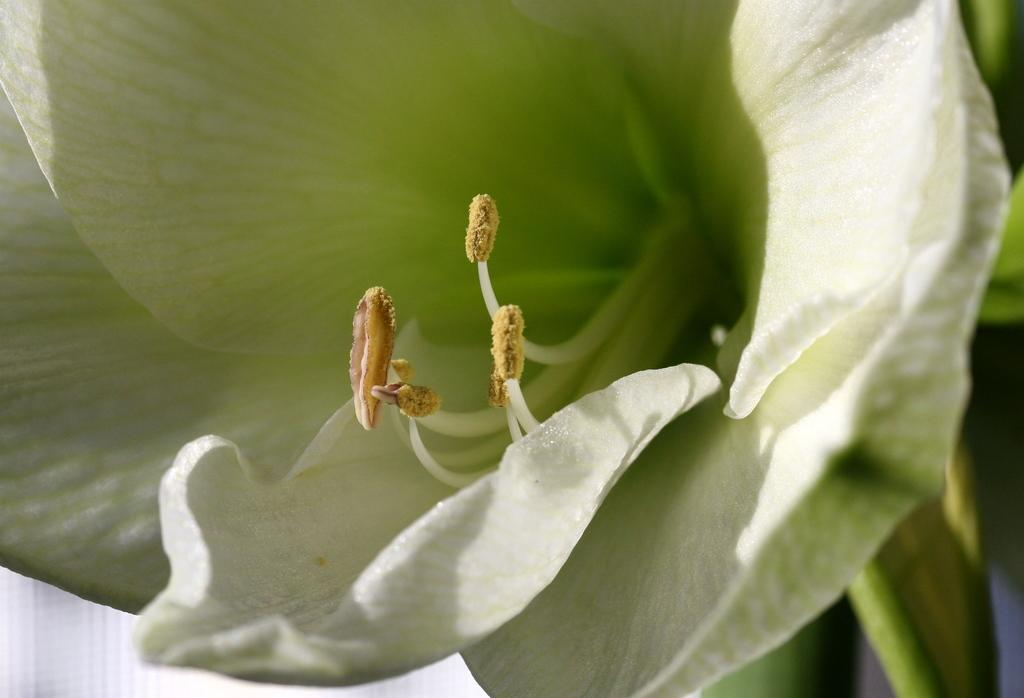What type of flower is present in the image? There is a green color flower in the picture. Can you describe the stage of the other flowers in the image? There are flower buds in the middle of the picture. What type of canvas is the farmer using to draw the chalk flower in the image? There is no farmer, canvas, or chalk present in the image. 